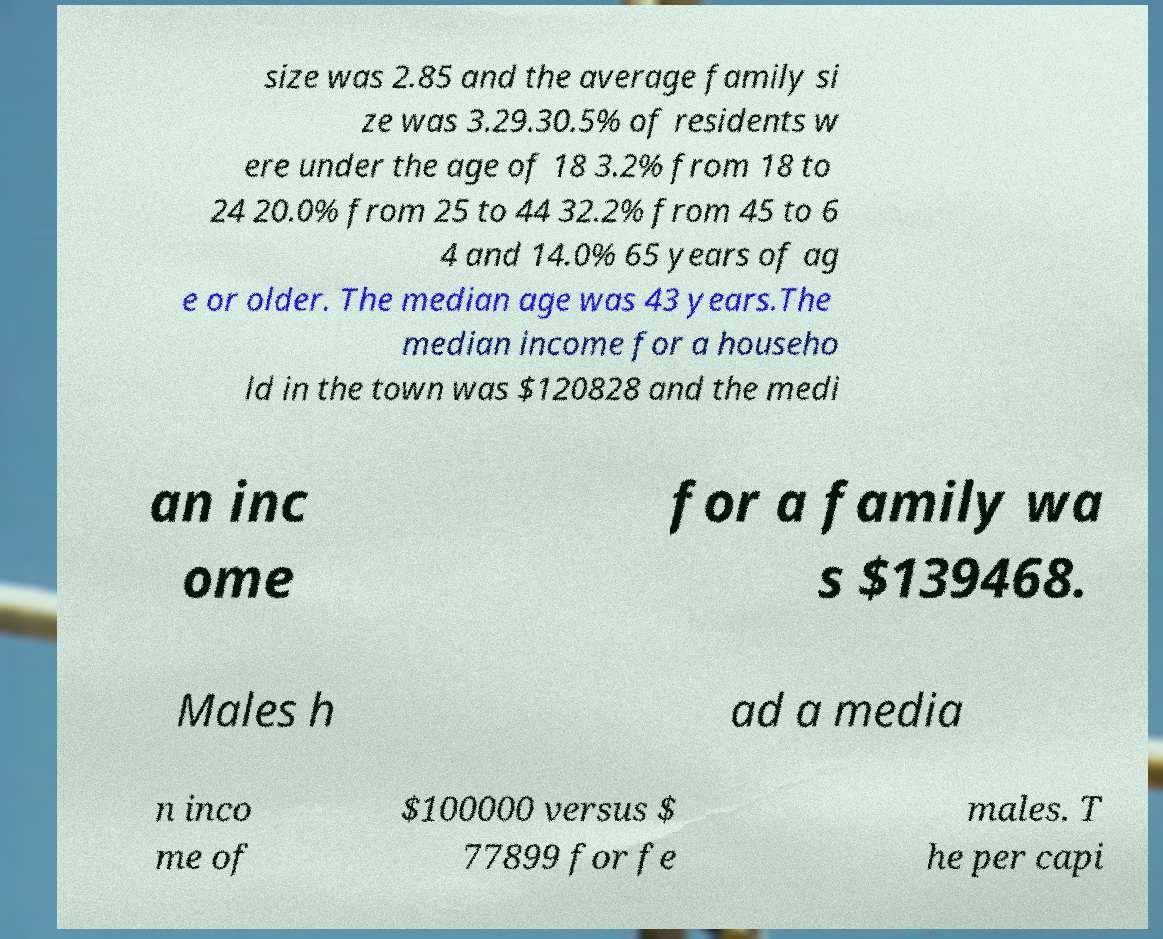I need the written content from this picture converted into text. Can you do that? size was 2.85 and the average family si ze was 3.29.30.5% of residents w ere under the age of 18 3.2% from 18 to 24 20.0% from 25 to 44 32.2% from 45 to 6 4 and 14.0% 65 years of ag e or older. The median age was 43 years.The median income for a househo ld in the town was $120828 and the medi an inc ome for a family wa s $139468. Males h ad a media n inco me of $100000 versus $ 77899 for fe males. T he per capi 